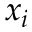<formula> <loc_0><loc_0><loc_500><loc_500>x _ { i }</formula> 